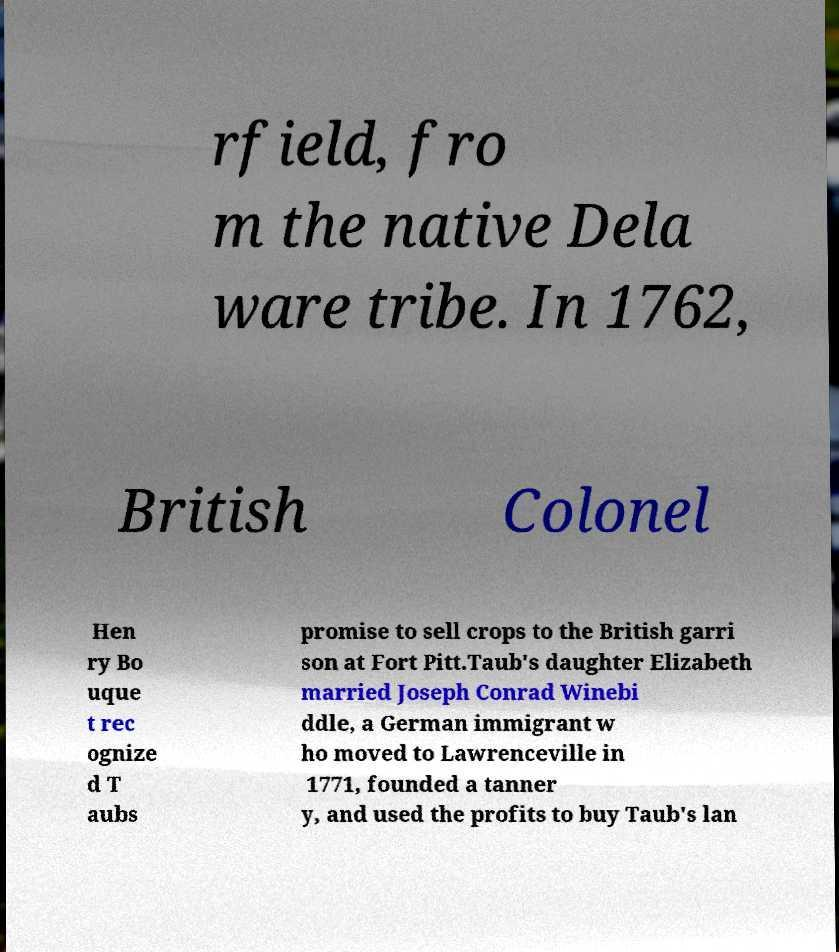Could you extract and type out the text from this image? rfield, fro m the native Dela ware tribe. In 1762, British Colonel Hen ry Bo uque t rec ognize d T aubs promise to sell crops to the British garri son at Fort Pitt.Taub's daughter Elizabeth married Joseph Conrad Winebi ddle, a German immigrant w ho moved to Lawrenceville in 1771, founded a tanner y, and used the profits to buy Taub's lan 